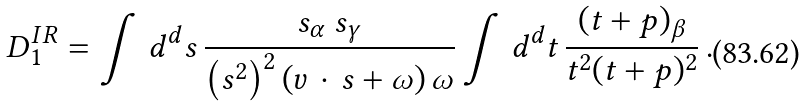<formula> <loc_0><loc_0><loc_500><loc_500>D _ { 1 } ^ { I R } = \int \, d ^ { d } s \, \frac { s _ { \alpha } \, s _ { \gamma } } { \left ( s ^ { 2 } \right ) ^ { 2 } ( v \, \cdot \, s + \omega ) \, \omega } \int \, d ^ { d } t \, \frac { ( t + p ) _ { \beta } } { t ^ { 2 } ( t + p ) ^ { 2 } } \, .</formula> 